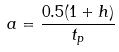<formula> <loc_0><loc_0><loc_500><loc_500>a = \frac { 0 . 5 ( 1 + h ) } { t _ { p } } \</formula> 